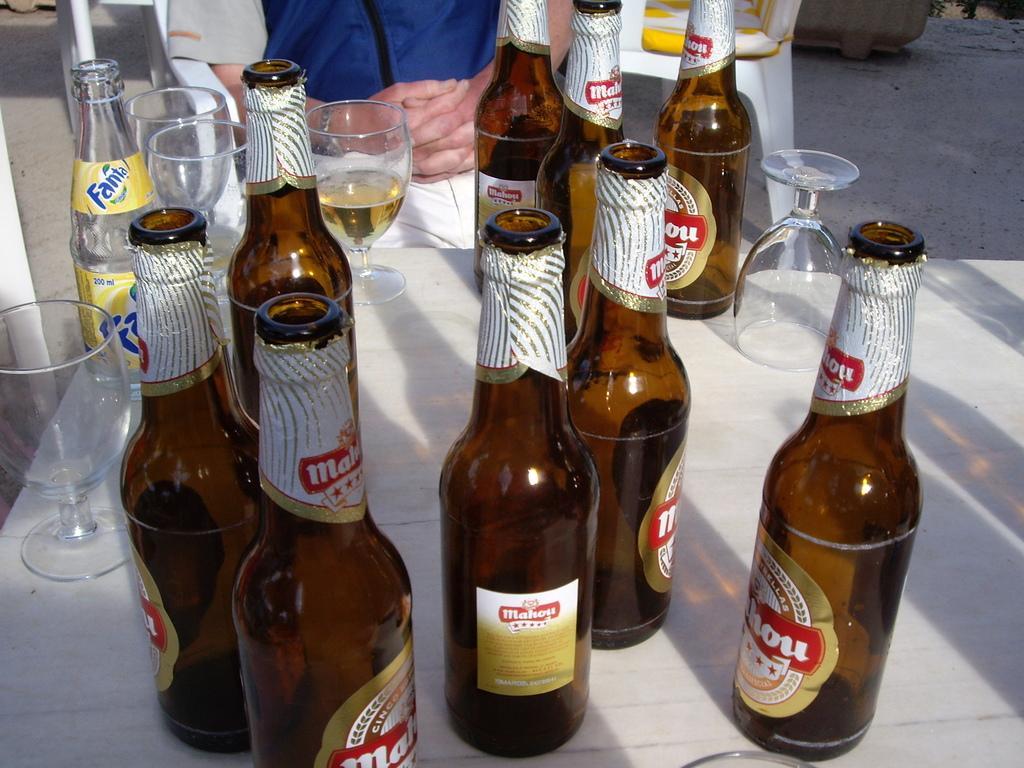In one or two sentences, can you explain what this image depicts? In this image, there is a table which is white color on that table there are some wine bottles which are in brown color and there are some glasses which are in white color, In the background there is man sitting on the chair. 